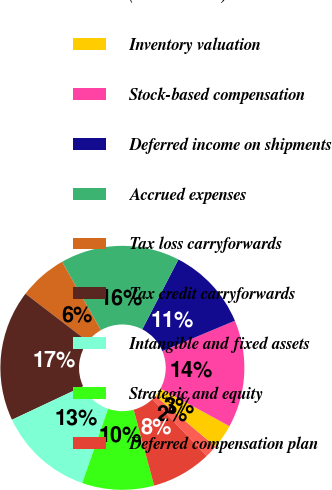Convert chart. <chart><loc_0><loc_0><loc_500><loc_500><pie_chart><fcel>(In thousands)<fcel>Inventory valuation<fcel>Stock-based compensation<fcel>Deferred income on shipments<fcel>Accrued expenses<fcel>Tax loss carryforwards<fcel>Tax credit carryforwards<fcel>Intangible and fixed assets<fcel>Strategic and equity<fcel>Deferred compensation plan<nl><fcel>1.67%<fcel>3.24%<fcel>14.25%<fcel>11.1%<fcel>15.82%<fcel>6.38%<fcel>17.39%<fcel>12.67%<fcel>9.53%<fcel>7.96%<nl></chart> 